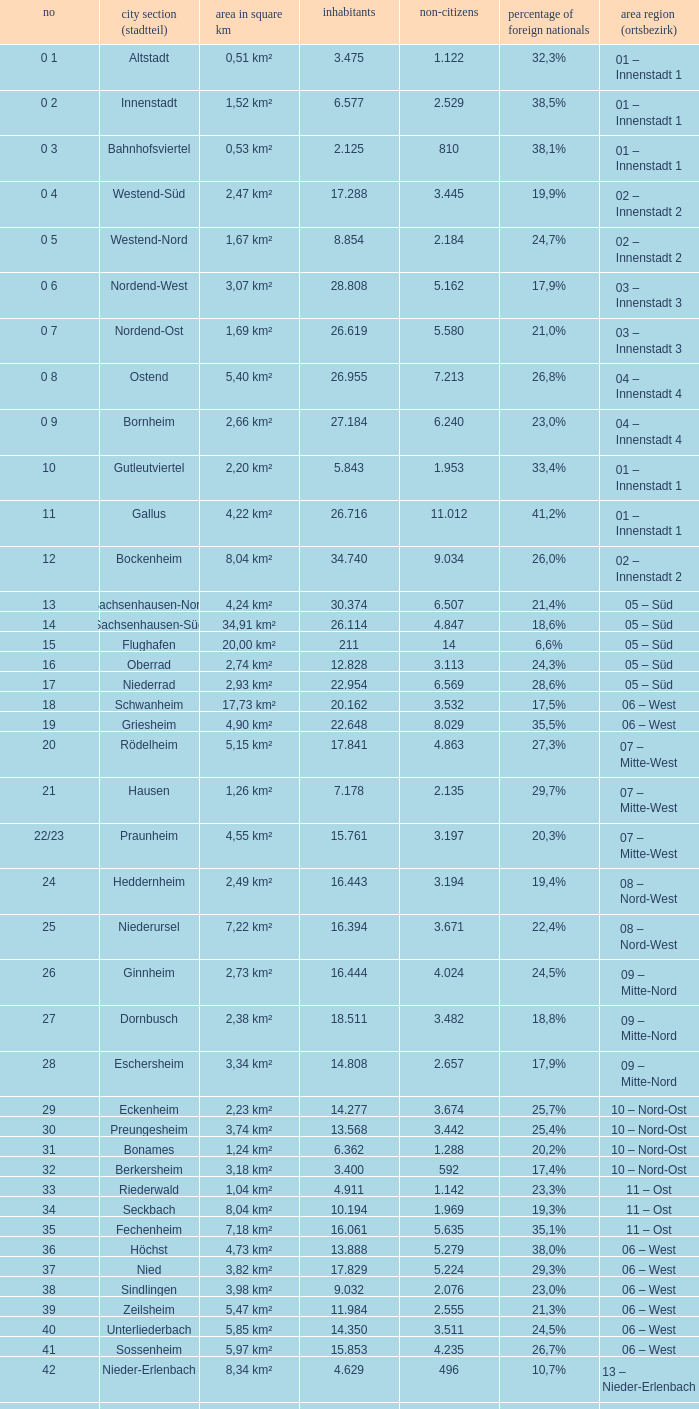What is the number of the city district of stadtteil where foreigners are 5.162? 1.0. 